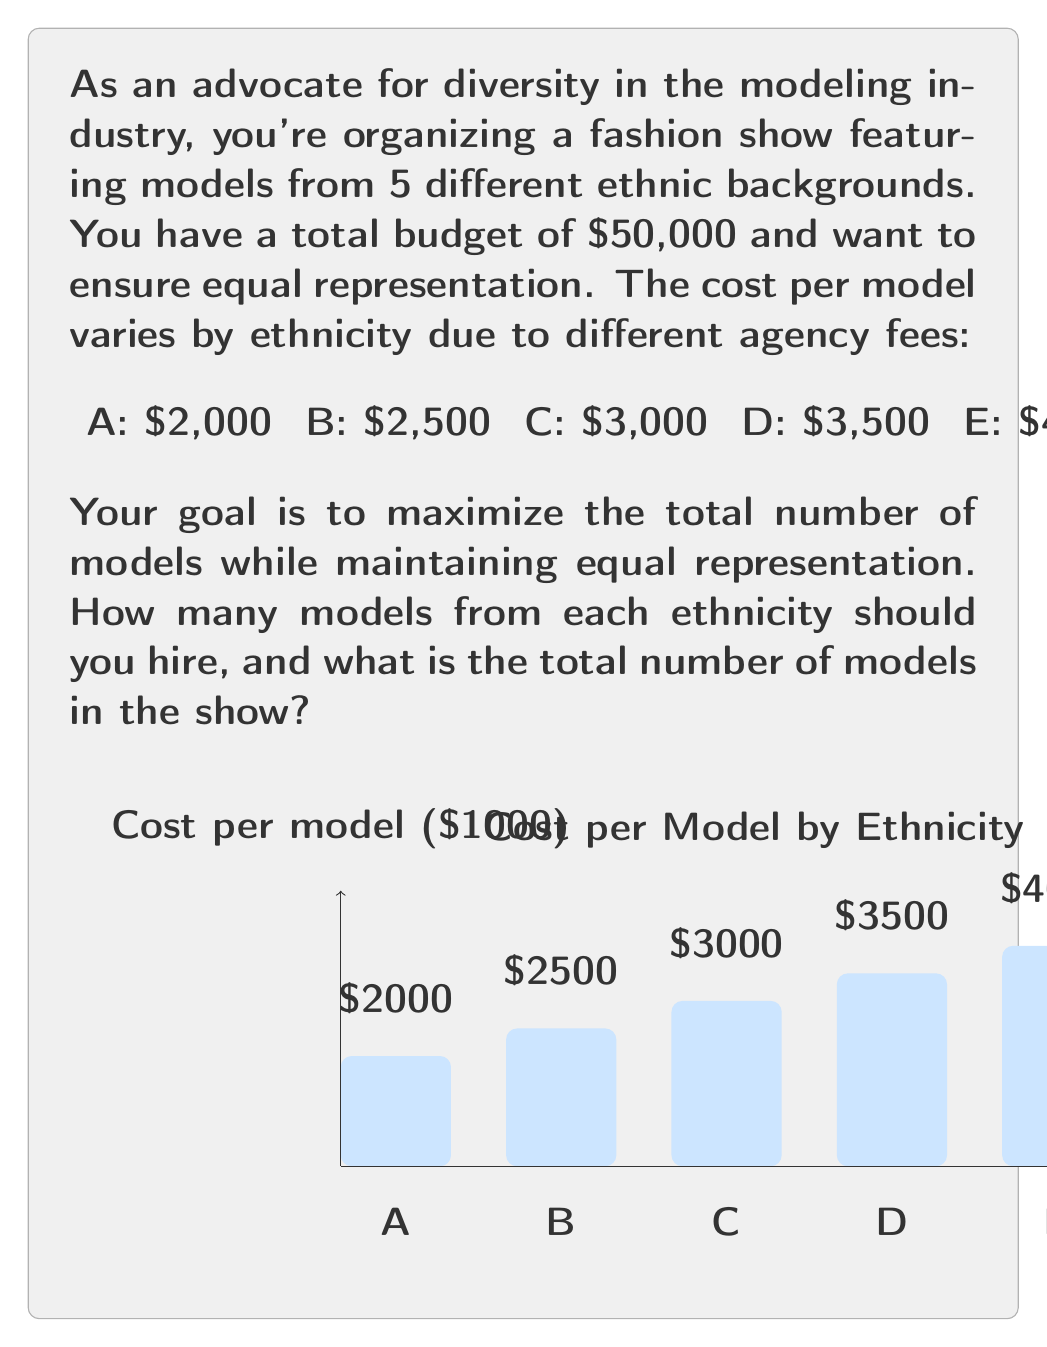Show me your answer to this math problem. Let's approach this step-by-step:

1) Let $x$ be the number of models from each ethnicity. Since we want equal representation, we'll hire $x$ models from each of the 5 ethnicities.

2) The total cost for all models can be expressed as:
   $$(2000x + 2500x + 3000x + 3500x + 4000x) = 50000$$

3) Simplify the left side of the equation:
   $$15000x = 50000$$

4) Solve for $x$:
   $$x = \frac{50000}{15000} = \frac{10}{3} \approx 3.33$$

5) Since we can't hire a fraction of a model, we need to round down to 3.
   $x = 3$

6) Let's verify if this fits within our budget:
   $$(2000 \cdot 3 + 2500 \cdot 3 + 3000 \cdot 3 + 3500 \cdot 3 + 4000 \cdot 3) = 45000$$

7) This is within our budget of $50,000, so our solution is valid.

8) The total number of models will be:
   $$3 \cdot 5 = 15$$

Therefore, we should hire 3 models from each of the 5 ethnicities, for a total of 15 models in the show.
Answer: 3 models from each ethnicity; 15 models total 